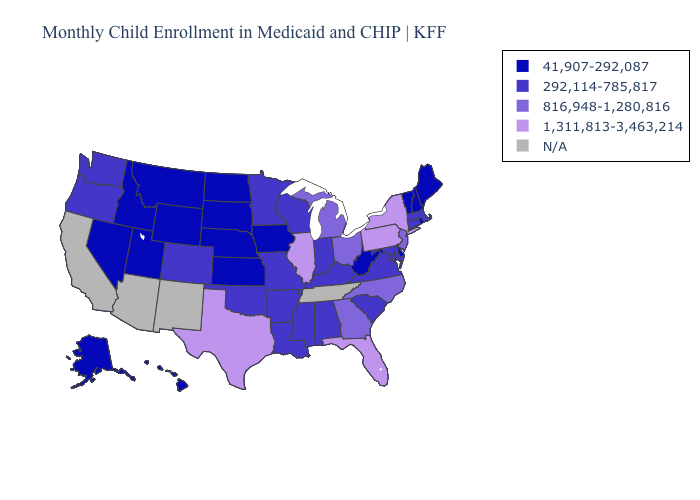Among the states that border South Dakota , which have the highest value?
Answer briefly. Minnesota. Name the states that have a value in the range 41,907-292,087?
Concise answer only. Alaska, Delaware, Hawaii, Idaho, Iowa, Kansas, Maine, Montana, Nebraska, Nevada, New Hampshire, North Dakota, Rhode Island, South Dakota, Utah, Vermont, West Virginia, Wyoming. Among the states that border Florida , which have the lowest value?
Keep it brief. Alabama. Does Michigan have the highest value in the MidWest?
Write a very short answer. No. Name the states that have a value in the range N/A?
Concise answer only. Arizona, California, New Mexico, Tennessee. Is the legend a continuous bar?
Quick response, please. No. Which states have the highest value in the USA?
Give a very brief answer. Florida, Illinois, New York, Pennsylvania, Texas. Which states hav the highest value in the Northeast?
Keep it brief. New York, Pennsylvania. Name the states that have a value in the range N/A?
Be succinct. Arizona, California, New Mexico, Tennessee. Name the states that have a value in the range 1,311,813-3,463,214?
Be succinct. Florida, Illinois, New York, Pennsylvania, Texas. Is the legend a continuous bar?
Be succinct. No. Name the states that have a value in the range 1,311,813-3,463,214?
Be succinct. Florida, Illinois, New York, Pennsylvania, Texas. Does Idaho have the lowest value in the West?
Give a very brief answer. Yes. What is the value of Washington?
Concise answer only. 292,114-785,817. 